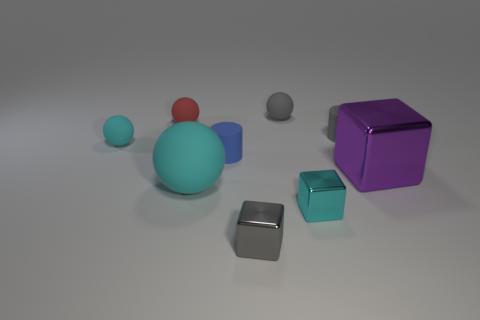Add 1 small brown matte balls. How many objects exist? 10 Subtract all cylinders. How many objects are left? 7 Subtract 1 gray cylinders. How many objects are left? 8 Subtract all small cyan metal cylinders. Subtract all big rubber spheres. How many objects are left? 8 Add 6 large purple cubes. How many large purple cubes are left? 7 Add 6 cyan rubber things. How many cyan rubber things exist? 8 